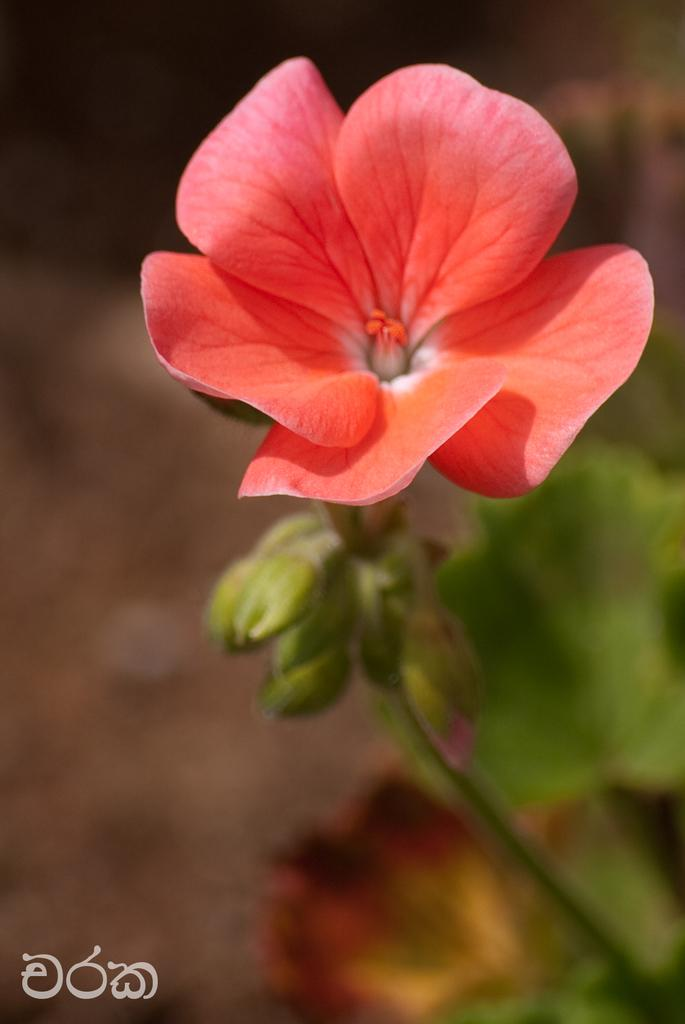What type of plant is visible in the image? There is a flower in the image. What else is present on the plant besides the flower? There are leaves in the image. What can be found in the bottom left corner of the image? There is text in the bottom left corner of the image. How would you describe the background of the image? The background of the image is blurred. What type of science experiment is being conducted in the image? There is no science experiment present in the image; it features a flower, leaves, text, and a blurred background. What type of feast is being prepared in the image? There is no feast being prepared in the image; it features a flower, leaves, text, and a blurred background. 